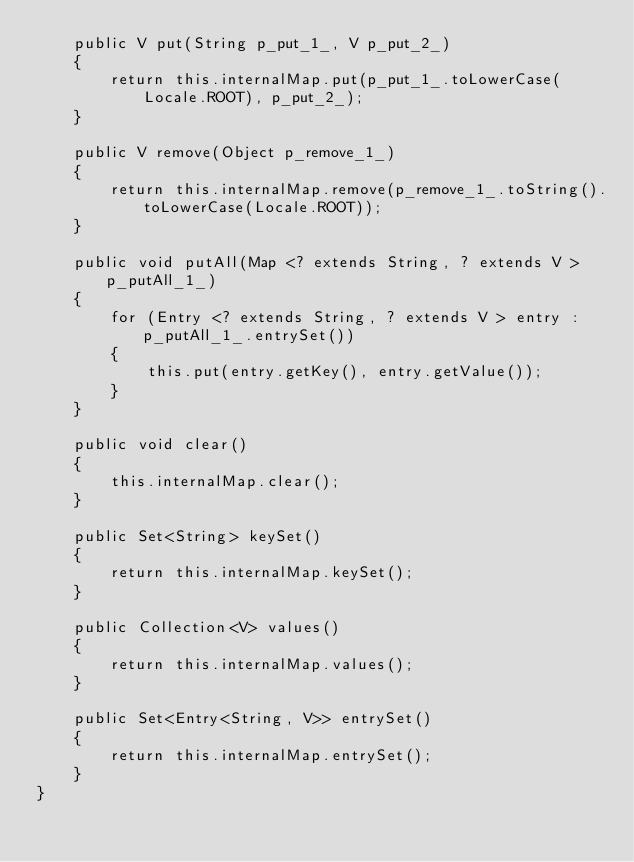<code> <loc_0><loc_0><loc_500><loc_500><_Java_>    public V put(String p_put_1_, V p_put_2_)
    {
        return this.internalMap.put(p_put_1_.toLowerCase(Locale.ROOT), p_put_2_);
    }

    public V remove(Object p_remove_1_)
    {
        return this.internalMap.remove(p_remove_1_.toString().toLowerCase(Locale.ROOT));
    }

    public void putAll(Map <? extends String, ? extends V > p_putAll_1_)
    {
        for (Entry <? extends String, ? extends V > entry : p_putAll_1_.entrySet())
        {
            this.put(entry.getKey(), entry.getValue());
        }
    }

    public void clear()
    {
        this.internalMap.clear();
    }

    public Set<String> keySet()
    {
        return this.internalMap.keySet();
    }

    public Collection<V> values()
    {
        return this.internalMap.values();
    }

    public Set<Entry<String, V>> entrySet()
    {
        return this.internalMap.entrySet();
    }
}</code> 